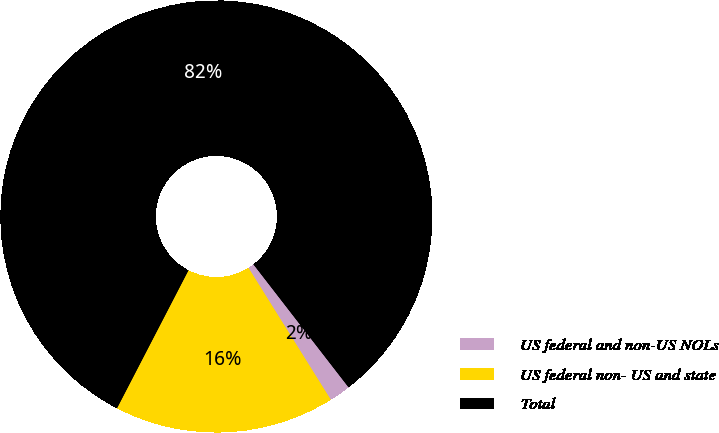Convert chart to OTSL. <chart><loc_0><loc_0><loc_500><loc_500><pie_chart><fcel>US federal and non-US NOLs<fcel>US federal non- US and state<fcel>Total<nl><fcel>1.6%<fcel>16.49%<fcel>81.91%<nl></chart> 